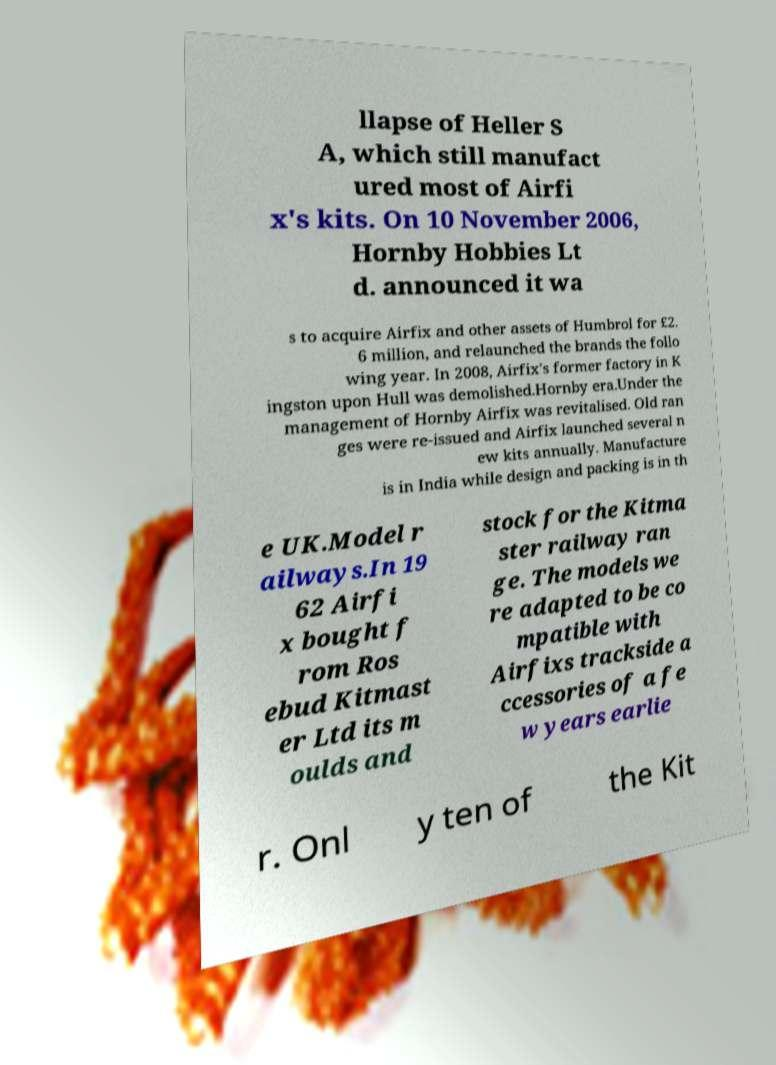I need the written content from this picture converted into text. Can you do that? llapse of Heller S A, which still manufact ured most of Airfi x's kits. On 10 November 2006, Hornby Hobbies Lt d. announced it wa s to acquire Airfix and other assets of Humbrol for £2. 6 million, and relaunched the brands the follo wing year. In 2008, Airfix's former factory in K ingston upon Hull was demolished.Hornby era.Under the management of Hornby Airfix was revitalised. Old ran ges were re-issued and Airfix launched several n ew kits annually. Manufacture is in India while design and packing is in th e UK.Model r ailways.In 19 62 Airfi x bought f rom Ros ebud Kitmast er Ltd its m oulds and stock for the Kitma ster railway ran ge. The models we re adapted to be co mpatible with Airfixs trackside a ccessories of a fe w years earlie r. Onl y ten of the Kit 